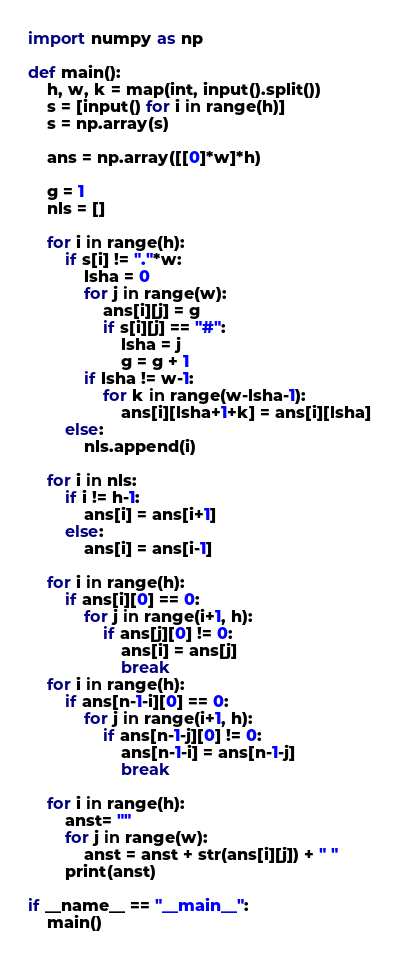<code> <loc_0><loc_0><loc_500><loc_500><_Python_>import numpy as np

def main():
    h, w, k = map(int, input().split())
    s = [input() for i in range(h)]
    s = np.array(s)

    ans = np.array([[0]*w]*h)

    g = 1
    nls = []

    for i in range(h):
        if s[i] != "."*w:
            lsha = 0
            for j in range(w):
                ans[i][j] = g
                if s[i][j] == "#":
                    lsha = j
                    g = g + 1
            if lsha != w-1:
                for k in range(w-lsha-1):
                    ans[i][lsha+1+k] = ans[i][lsha] 
        else:
            nls.append(i)
    
    for i in nls:
        if i != h-1:
            ans[i] = ans[i+1]
        else:
            ans[i] = ans[i-1]
    
    for i in range(h):
        if ans[i][0] == 0:
            for j in range(i+1, h):
                if ans[j][0] != 0:
                    ans[i] = ans[j]
                    break
    for i in range(h):
        if ans[n-1-i][0] == 0:
            for j in range(i+1, h):
                if ans[n-1-j][0] != 0:
                    ans[n-1-i] = ans[n-1-j]
                    break
    
    for i in range(h):
        anst= ""
        for j in range(w):
            anst = anst + str(ans[i][j]) + " "
        print(anst)

if __name__ == "__main__":
    main()</code> 